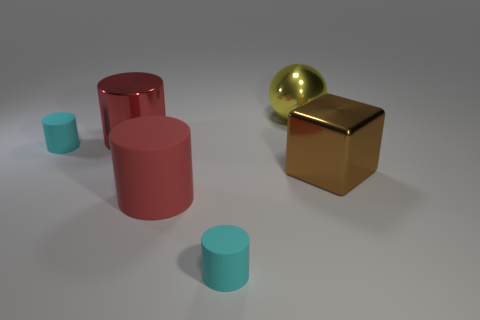Add 2 rubber things. How many objects exist? 8 Subtract all cylinders. How many objects are left? 2 Subtract all large brown things. Subtract all red objects. How many objects are left? 3 Add 4 large yellow metal things. How many large yellow metal things are left? 5 Add 2 big brown blocks. How many big brown blocks exist? 3 Subtract 2 cyan cylinders. How many objects are left? 4 